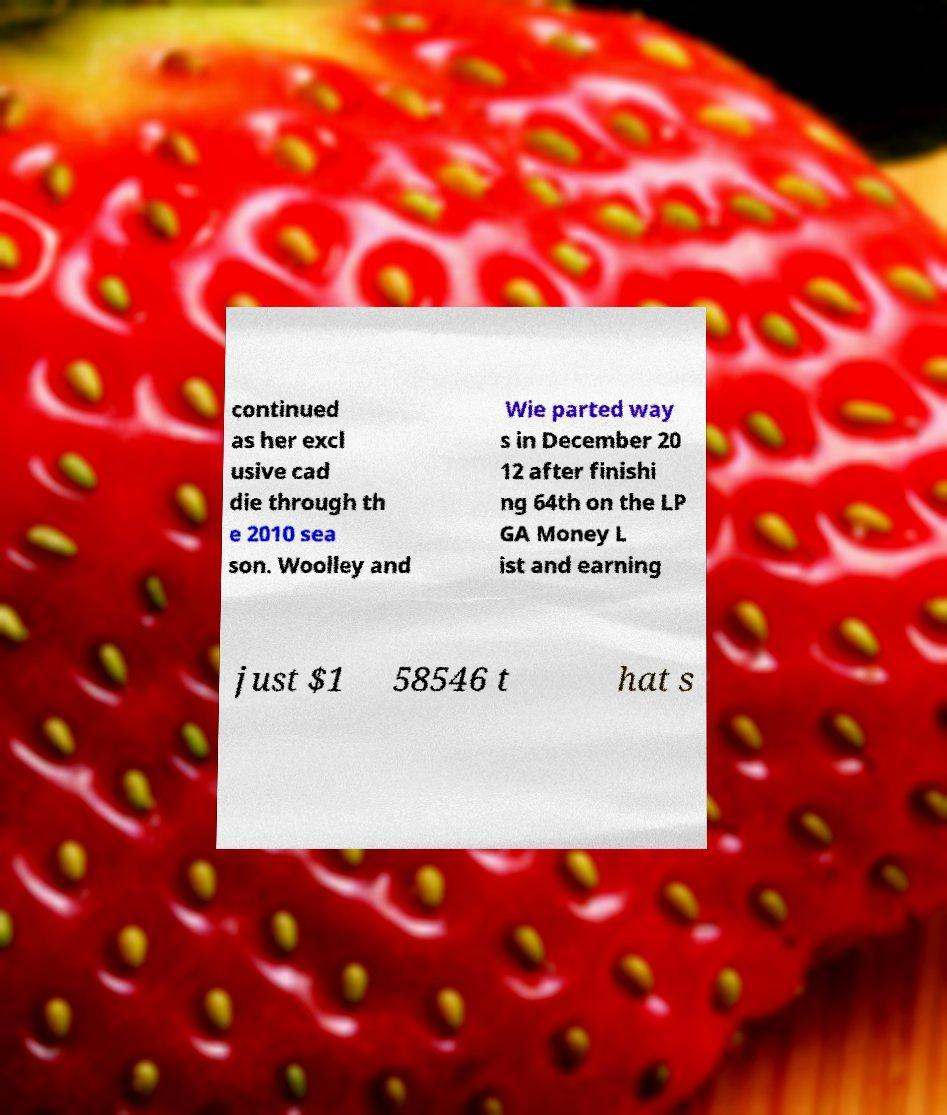What messages or text are displayed in this image? I need them in a readable, typed format. continued as her excl usive cad die through th e 2010 sea son. Woolley and Wie parted way s in December 20 12 after finishi ng 64th on the LP GA Money L ist and earning just $1 58546 t hat s 